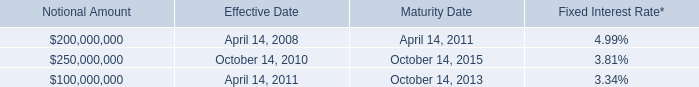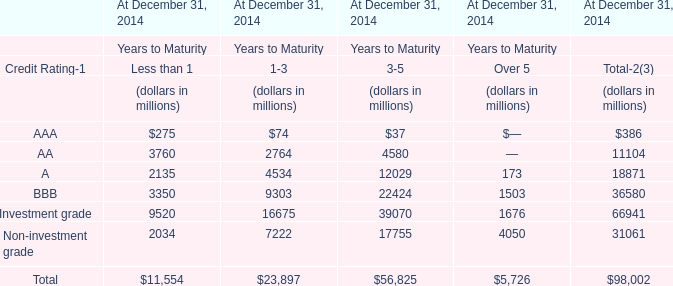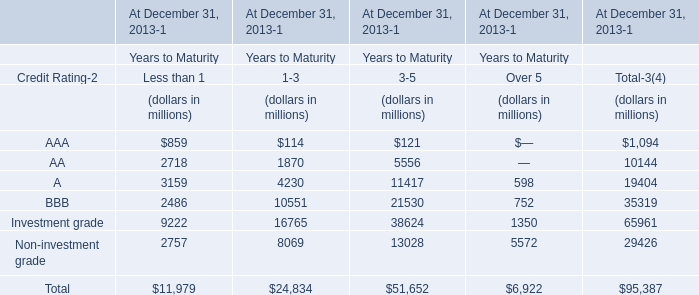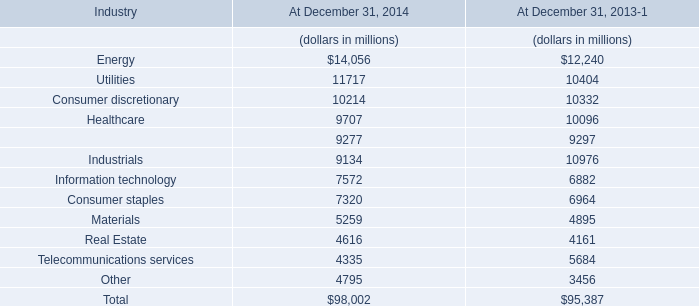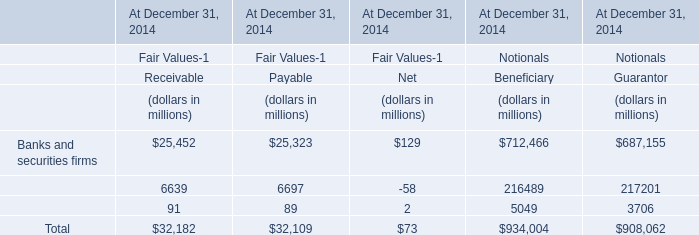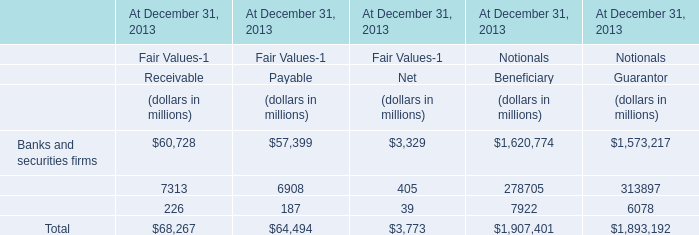What's the sum of all elements that are greater than 5000 for 3-5? (in million) 
Computations: (((5556 + 11417) + 21530) + 13028)
Answer: 51531.0. 